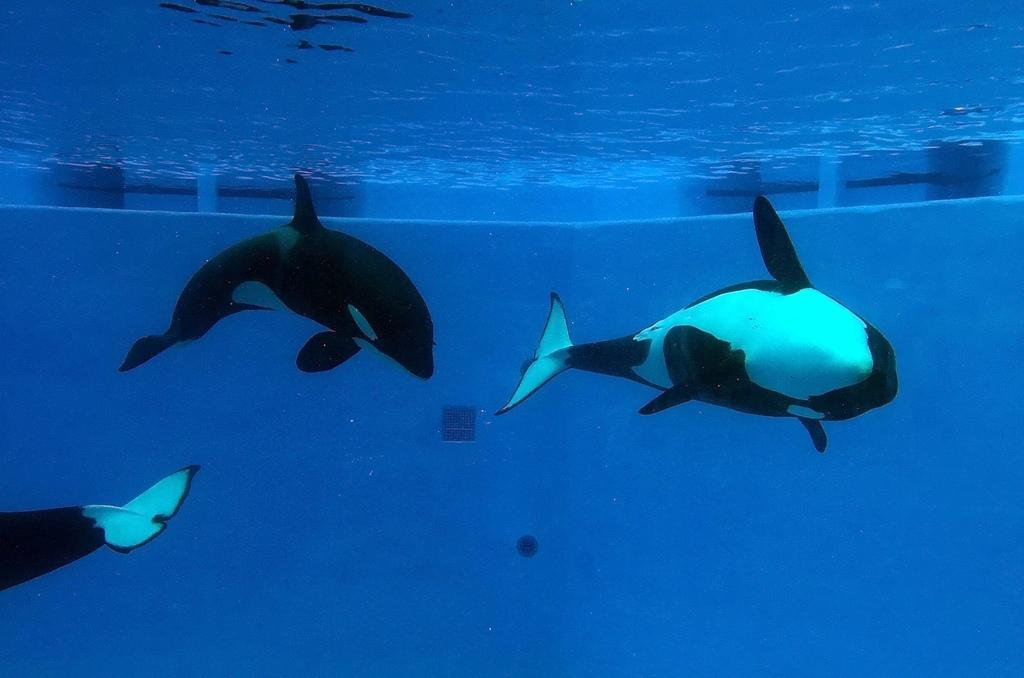What type of natural feature can be seen in the image? There is a water body in the image. What animals are present in the water? Dolphins are visible in the water. What type of muscle is being exercised by the dolphins in the image? There is no indication in the image that the dolphins are exercising any specific muscle. 